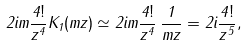Convert formula to latex. <formula><loc_0><loc_0><loc_500><loc_500>2 i m \frac { 4 ! } { z ^ { 4 } } K _ { 1 } ( m z ) \simeq 2 i m \frac { 4 ! } { z ^ { 4 } } \, \frac { 1 } { m z } = 2 i \frac { 4 ! } { z ^ { 5 } } ,</formula> 